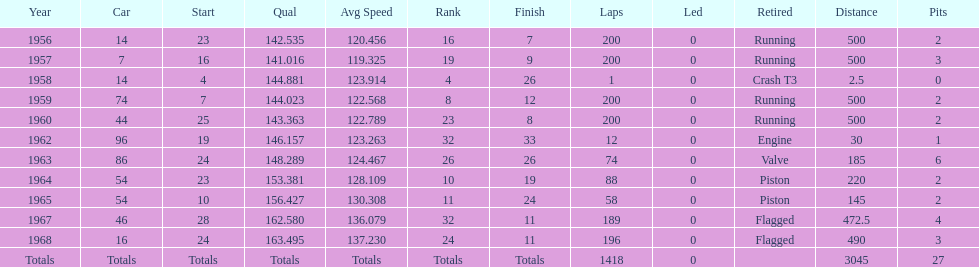Which year is the last qual on the chart 1968. 